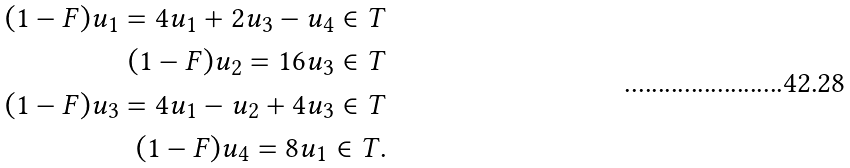Convert formula to latex. <formula><loc_0><loc_0><loc_500><loc_500>( 1 - F ) u _ { 1 } = 4 u _ { 1 } + 2 u _ { 3 } - u _ { 4 } \in T \\ ( 1 - F ) u _ { 2 } = 1 6 u _ { 3 } \in T \\ ( 1 - F ) u _ { 3 } = 4 u _ { 1 } - u _ { 2 } + 4 u _ { 3 } \in T \\ ( 1 - F ) u _ { 4 } = 8 u _ { 1 } \in T . \\</formula> 